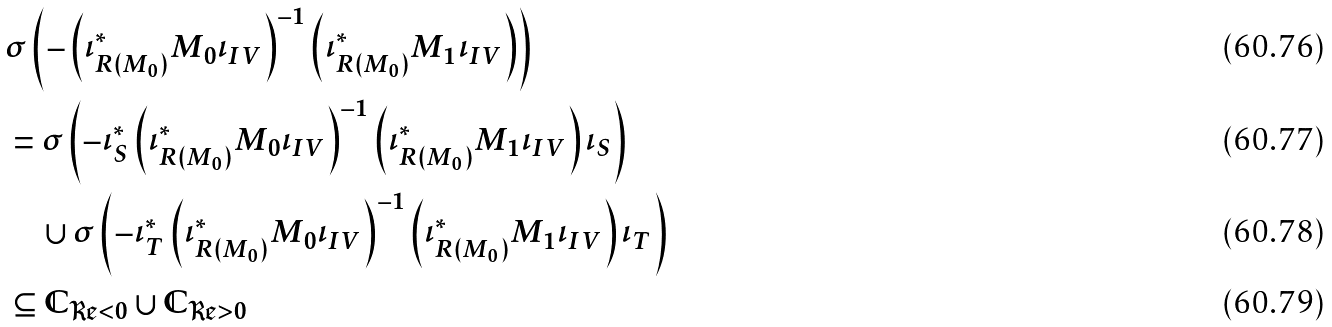<formula> <loc_0><loc_0><loc_500><loc_500>& \sigma \left ( - \left ( \iota _ { R ( M _ { 0 } ) } ^ { \ast } M _ { 0 } \iota _ { I V } \right ) ^ { - 1 } \left ( \iota _ { R ( M _ { 0 } ) } ^ { \ast } M _ { 1 } \iota _ { I V } \right ) \right ) \\ & = \sigma \left ( - \iota _ { S } ^ { \ast } \left ( \iota _ { R ( M _ { 0 } ) } ^ { \ast } M _ { 0 } \iota _ { I V } \right ) ^ { - 1 } \left ( \iota _ { R ( M _ { 0 } ) } ^ { \ast } M _ { 1 } \iota _ { I V } \right ) \iota _ { S } \right ) \\ & \quad \cup \sigma \left ( - \iota _ { T } ^ { \ast } \left ( \iota _ { R ( M _ { 0 } ) } ^ { \ast } M _ { 0 } \iota _ { I V } \right ) ^ { - 1 } \left ( \iota _ { R ( M _ { 0 } ) } ^ { \ast } M _ { 1 } \iota _ { I V } \right ) \iota _ { T } \right ) \\ & \subseteq \mathbb { C } _ { \Re < 0 } \cup \mathbb { C } _ { \Re > 0 }</formula> 